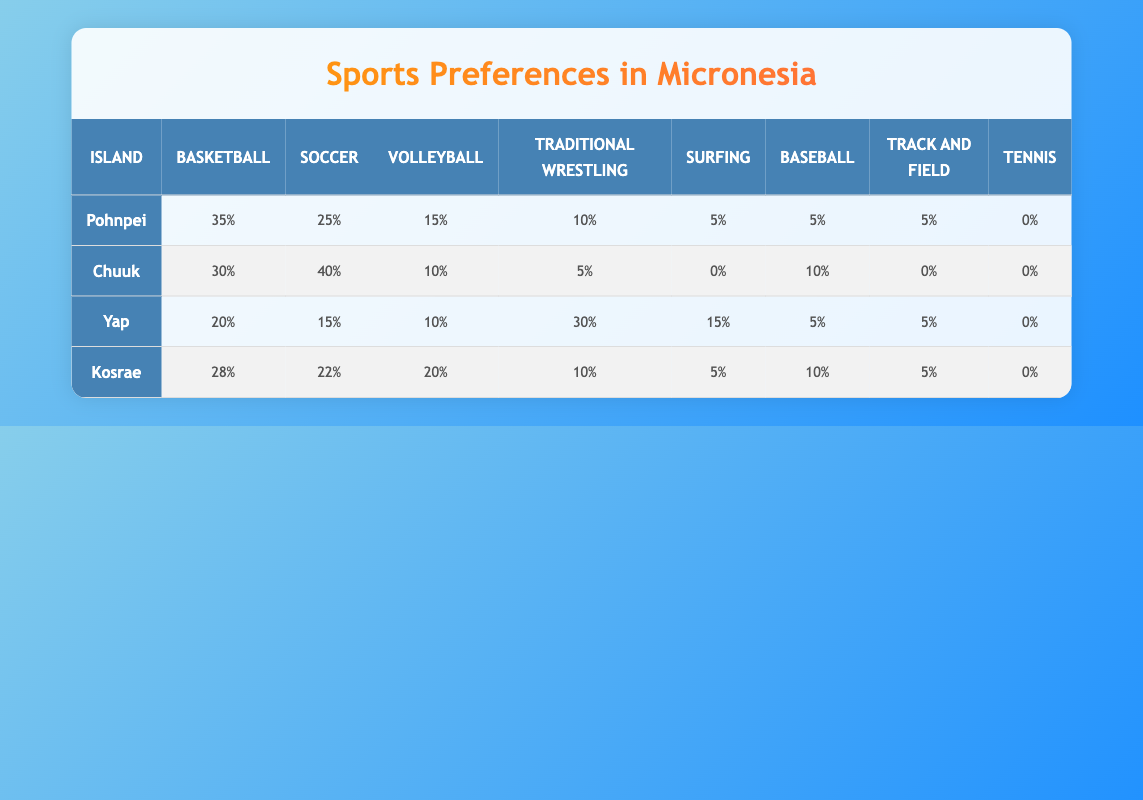What is the most popular sport in Pohnpei? The table shows that Basketball has the highest value of 35 in Pohnpei's row. Therefore, it is the most popular sport on that island.
Answer: Basketball How many sports have a preference value of 10 or more in Chuuk? By examining the Chuuk row, the sports with values 10 or more are Soccer (40), Basketball (30), and Baseball (10). This results in a total of 3 sports.
Answer: 3 Which island has the highest participation in Traditional Wrestling? Looking at the Traditional Wrestling numbers, Yap has the highest number at 30, as compared to Pohnpei (10), Chuuk (5), and Kosrae (10). This confirms Yap as the island with the highest participation in this sport.
Answer: Yap What is the total preference value for Volleyball across all islands? By summing the Volleyball values: Pohnpei (15) + Chuuk (10) + Yap (10) + Kosrae (20) = 55. Therefore, the total preference value for Volleyball is 55.
Answer: 55 Is there any island where Tennis has a preference value greater than zero? The table shows that Tennis has a preference value of 0 across all islands, so there is no island with a value greater than zero.
Answer: No Which island has the lowest participation in Surfing? The Surfing values are Pohnpei (5), Chuuk (0), Yap (15), and Kosrae (5). Chuuk has the lowest value of 0 for Surfing.
Answer: Chuuk What is the average participation value for Baseball among all islands? The Baseball values are: Pohnpei (5), Chuuk (10), Yap (5), and Kosrae (10). Adding these gives a total of 30, dividing by 4 (number of islands) results in an average of 7.5.
Answer: 7.5 Which sport has the highest total preference across all islands? Calculating the total for each sport: Basketball (35 + 30 + 20 + 28 = 113), Soccer (25 + 40 + 15 + 22 = 102), Volleyball (15 + 10 + 10 + 20 = 55), Traditional Wrestling (10 + 5 + 30 + 10 = 55), Surfing (5 + 0 + 15 + 5 = 25), Baseball (5 + 10 + 5 + 10 = 30), Track and Field (5 + 0 + 5 + 5 = 15), Tennis (0 in all). Basketball has the highest total preference of 113.
Answer: Basketball 